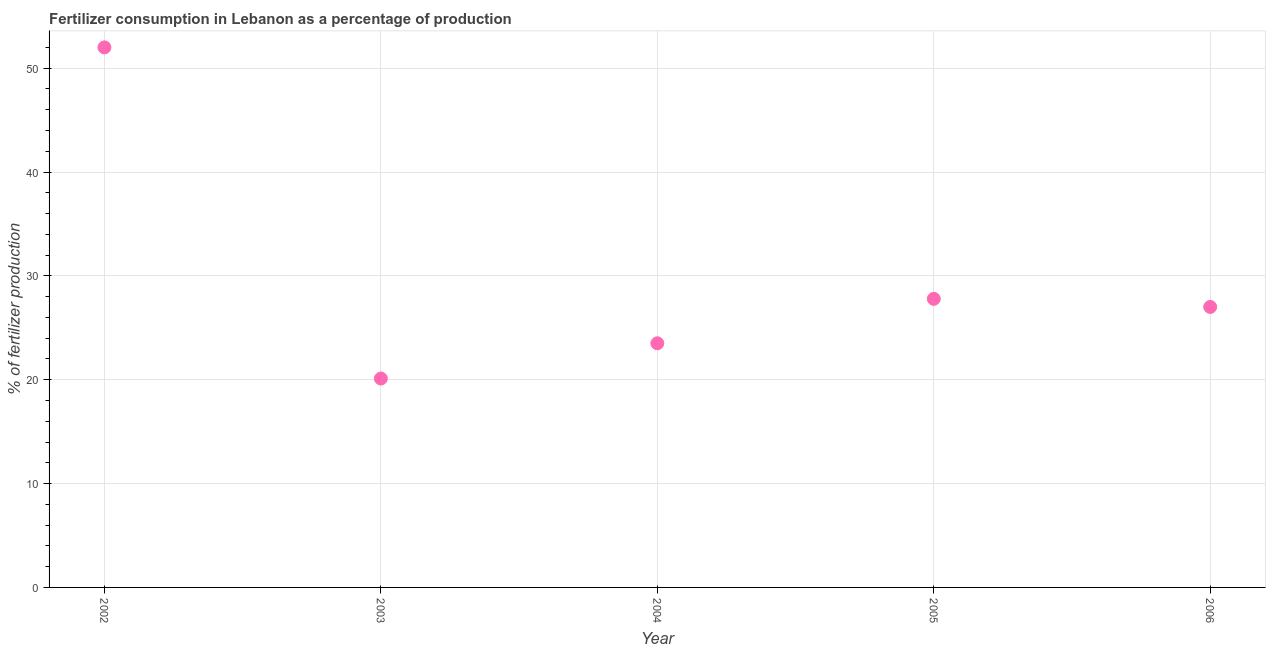What is the amount of fertilizer consumption in 2004?
Offer a very short reply. 23.51. Across all years, what is the maximum amount of fertilizer consumption?
Your response must be concise. 52. Across all years, what is the minimum amount of fertilizer consumption?
Provide a succinct answer. 20.12. In which year was the amount of fertilizer consumption minimum?
Your answer should be very brief. 2003. What is the sum of the amount of fertilizer consumption?
Make the answer very short. 150.42. What is the difference between the amount of fertilizer consumption in 2002 and 2006?
Make the answer very short. 24.99. What is the average amount of fertilizer consumption per year?
Provide a succinct answer. 30.08. What is the median amount of fertilizer consumption?
Keep it short and to the point. 27.01. In how many years, is the amount of fertilizer consumption greater than 24 %?
Provide a short and direct response. 3. What is the ratio of the amount of fertilizer consumption in 2002 to that in 2005?
Offer a terse response. 1.87. Is the amount of fertilizer consumption in 2002 less than that in 2003?
Keep it short and to the point. No. Is the difference between the amount of fertilizer consumption in 2005 and 2006 greater than the difference between any two years?
Your response must be concise. No. What is the difference between the highest and the second highest amount of fertilizer consumption?
Make the answer very short. 24.21. Is the sum of the amount of fertilizer consumption in 2004 and 2005 greater than the maximum amount of fertilizer consumption across all years?
Provide a succinct answer. No. What is the difference between the highest and the lowest amount of fertilizer consumption?
Provide a short and direct response. 31.88. In how many years, is the amount of fertilizer consumption greater than the average amount of fertilizer consumption taken over all years?
Offer a very short reply. 1. Does the amount of fertilizer consumption monotonically increase over the years?
Offer a very short reply. No. Are the values on the major ticks of Y-axis written in scientific E-notation?
Keep it short and to the point. No. Does the graph contain any zero values?
Ensure brevity in your answer.  No. What is the title of the graph?
Your answer should be very brief. Fertilizer consumption in Lebanon as a percentage of production. What is the label or title of the Y-axis?
Keep it short and to the point. % of fertilizer production. What is the % of fertilizer production in 2002?
Provide a succinct answer. 52. What is the % of fertilizer production in 2003?
Keep it short and to the point. 20.12. What is the % of fertilizer production in 2004?
Your response must be concise. 23.51. What is the % of fertilizer production in 2005?
Ensure brevity in your answer.  27.79. What is the % of fertilizer production in 2006?
Make the answer very short. 27.01. What is the difference between the % of fertilizer production in 2002 and 2003?
Your answer should be very brief. 31.88. What is the difference between the % of fertilizer production in 2002 and 2004?
Ensure brevity in your answer.  28.49. What is the difference between the % of fertilizer production in 2002 and 2005?
Your answer should be very brief. 24.21. What is the difference between the % of fertilizer production in 2002 and 2006?
Your answer should be compact. 24.99. What is the difference between the % of fertilizer production in 2003 and 2004?
Your answer should be very brief. -3.39. What is the difference between the % of fertilizer production in 2003 and 2005?
Your answer should be very brief. -7.67. What is the difference between the % of fertilizer production in 2003 and 2006?
Make the answer very short. -6.89. What is the difference between the % of fertilizer production in 2004 and 2005?
Keep it short and to the point. -4.28. What is the difference between the % of fertilizer production in 2004 and 2006?
Keep it short and to the point. -3.5. What is the difference between the % of fertilizer production in 2005 and 2006?
Make the answer very short. 0.78. What is the ratio of the % of fertilizer production in 2002 to that in 2003?
Ensure brevity in your answer.  2.58. What is the ratio of the % of fertilizer production in 2002 to that in 2004?
Your answer should be very brief. 2.21. What is the ratio of the % of fertilizer production in 2002 to that in 2005?
Ensure brevity in your answer.  1.87. What is the ratio of the % of fertilizer production in 2002 to that in 2006?
Offer a very short reply. 1.93. What is the ratio of the % of fertilizer production in 2003 to that in 2004?
Provide a short and direct response. 0.86. What is the ratio of the % of fertilizer production in 2003 to that in 2005?
Offer a terse response. 0.72. What is the ratio of the % of fertilizer production in 2003 to that in 2006?
Offer a terse response. 0.74. What is the ratio of the % of fertilizer production in 2004 to that in 2005?
Offer a very short reply. 0.85. What is the ratio of the % of fertilizer production in 2004 to that in 2006?
Your answer should be very brief. 0.87. What is the ratio of the % of fertilizer production in 2005 to that in 2006?
Offer a very short reply. 1.03. 